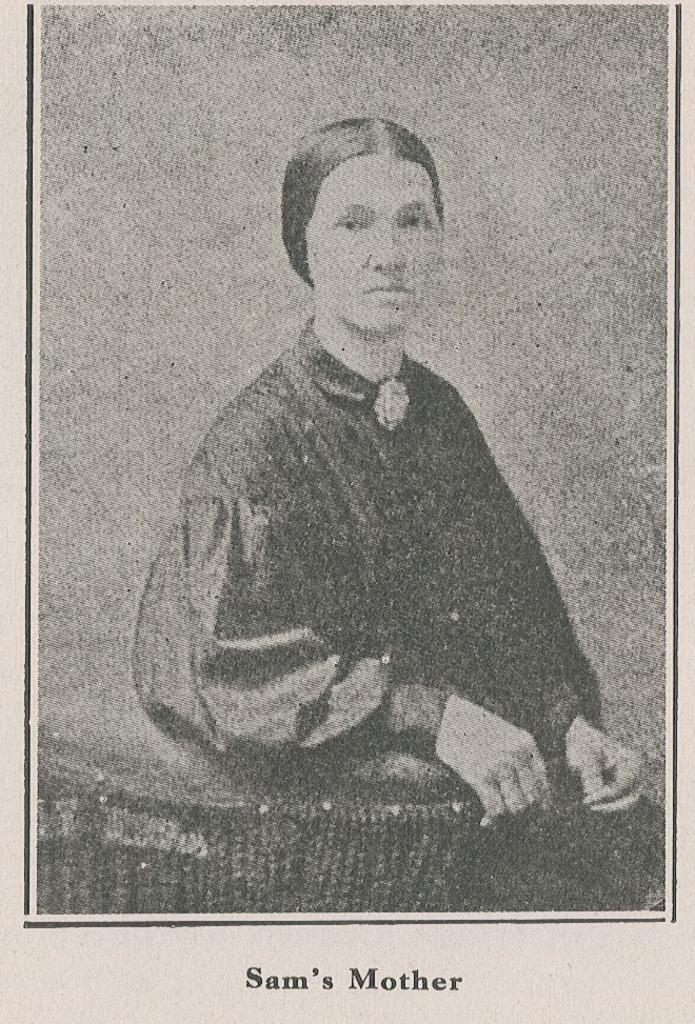Could you give a brief overview of what you see in this image? In this image, I can see a paper with the photo of a woman sitting on a chair. At the bottom of the image, there are words. 